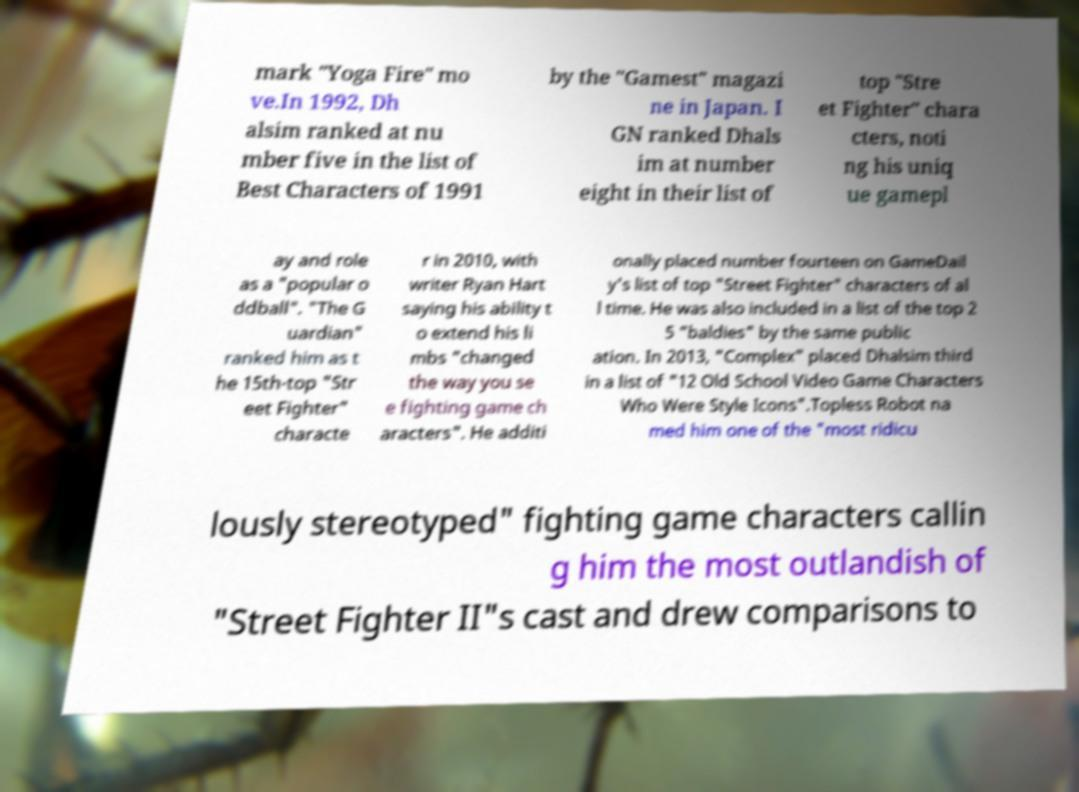Could you extract and type out the text from this image? mark "Yoga Fire" mo ve.In 1992, Dh alsim ranked at nu mber five in the list of Best Characters of 1991 by the "Gamest" magazi ne in Japan. I GN ranked Dhals im at number eight in their list of top "Stre et Fighter" chara cters, noti ng his uniq ue gamepl ay and role as a "popular o ddball". "The G uardian" ranked him as t he 15th-top "Str eet Fighter" characte r in 2010, with writer Ryan Hart saying his ability t o extend his li mbs "changed the way you se e fighting game ch aracters". He additi onally placed number fourteen on GameDail y's list of top "Street Fighter" characters of al l time. He was also included in a list of the top 2 5 "baldies" by the same public ation. In 2013, "Complex" placed Dhalsim third in a list of "12 Old School Video Game Characters Who Were Style Icons".Topless Robot na med him one of the "most ridicu lously stereotyped" fighting game characters callin g him the most outlandish of "Street Fighter II"s cast and drew comparisons to 